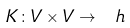<formula> <loc_0><loc_0><loc_500><loc_500>K \colon V \times V \to \ h</formula> 